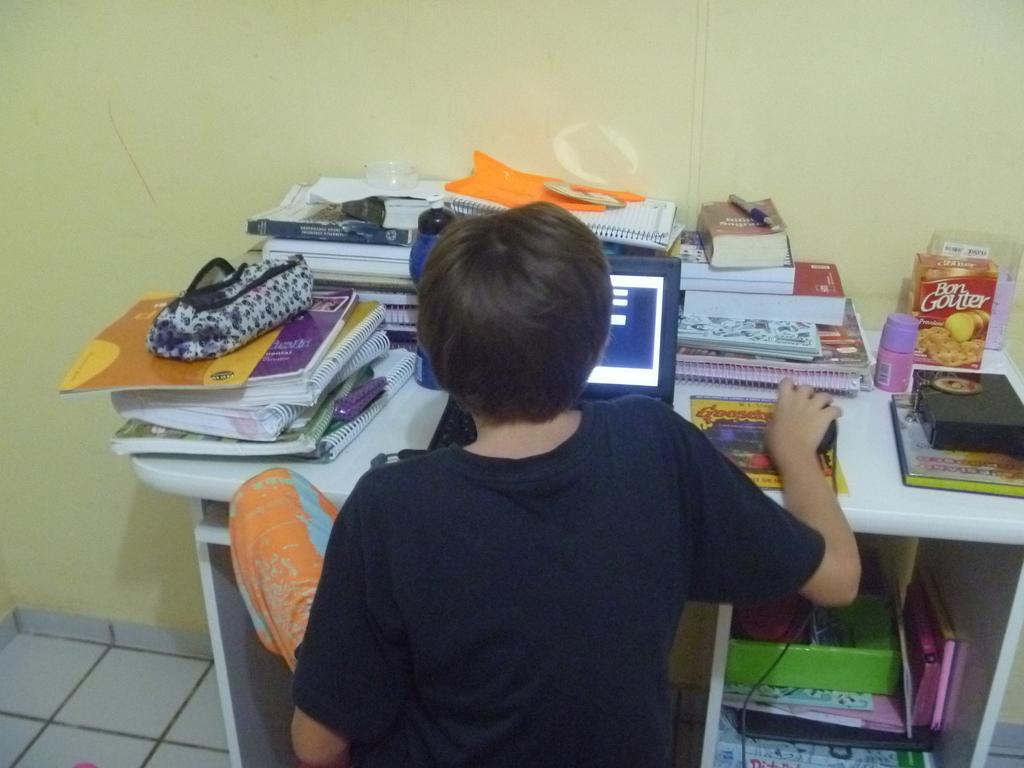How would you summarize this image in a sentence or two? In this image I can see a kid working on the laptop. I can see the books and some other objects on the table. 